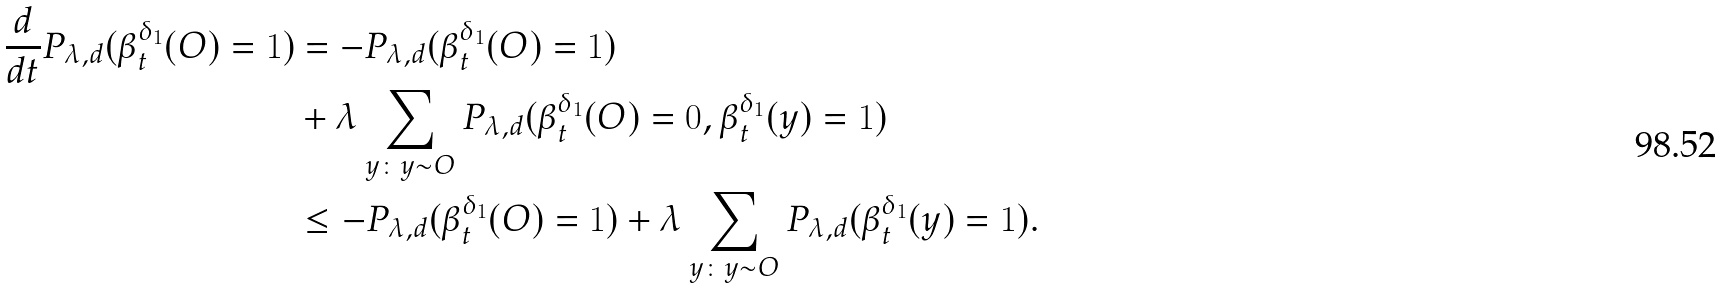<formula> <loc_0><loc_0><loc_500><loc_500>\frac { d } { d t } P _ { \lambda , d } ( \beta _ { t } ^ { \delta _ { 1 } } ( O ) = 1 ) & = - P _ { \lambda , d } ( \beta _ { t } ^ { \delta _ { 1 } } ( O ) = 1 ) \\ & + \lambda \sum _ { y \colon y \sim O } P _ { \lambda , d } ( \beta _ { t } ^ { \delta _ { 1 } } ( O ) = 0 , \beta _ { t } ^ { \delta _ { 1 } } ( y ) = 1 ) \\ & \leq - P _ { \lambda , d } ( \beta _ { t } ^ { \delta _ { 1 } } ( O ) = 1 ) + \lambda \sum _ { y \colon y \sim O } P _ { \lambda , d } ( \beta _ { t } ^ { \delta _ { 1 } } ( y ) = 1 ) .</formula> 